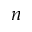<formula> <loc_0><loc_0><loc_500><loc_500>n</formula> 